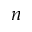<formula> <loc_0><loc_0><loc_500><loc_500>n</formula> 